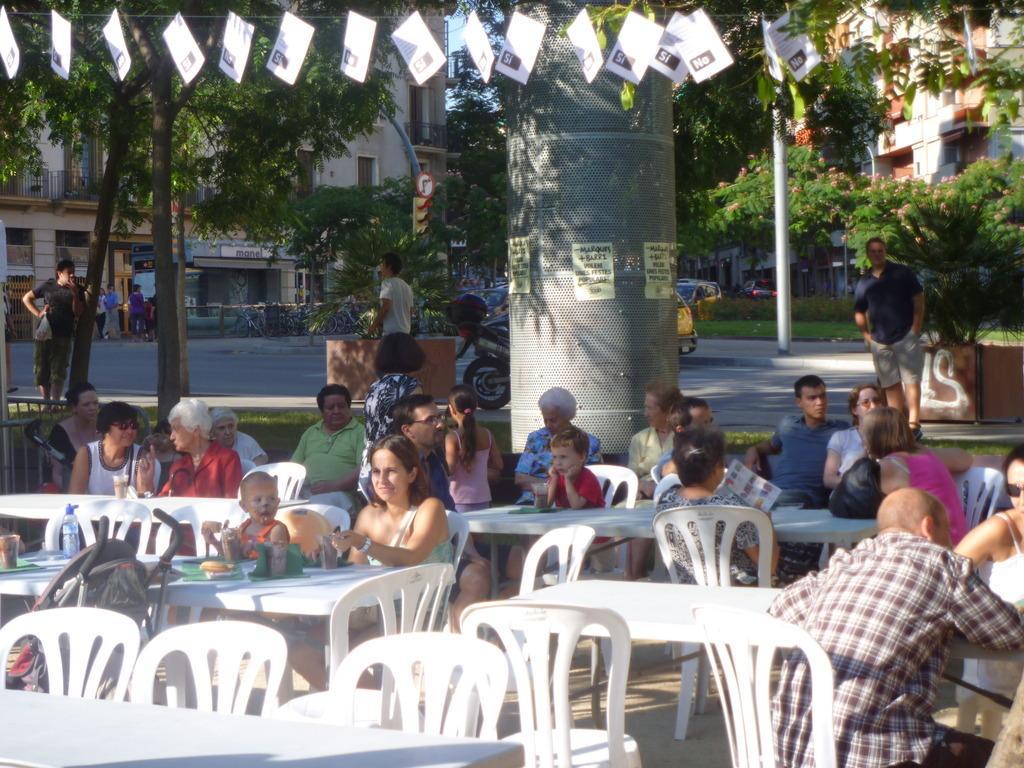How would you summarize this image in a sentence or two? The photo is taken outside a building. In the foreground there are many chairs and tables,people are sitting. On the table there are food and bottle. There is a big pillar in the middle. there are few people walking by the street and vehicles on the street. In the background there are trees , buildings. 